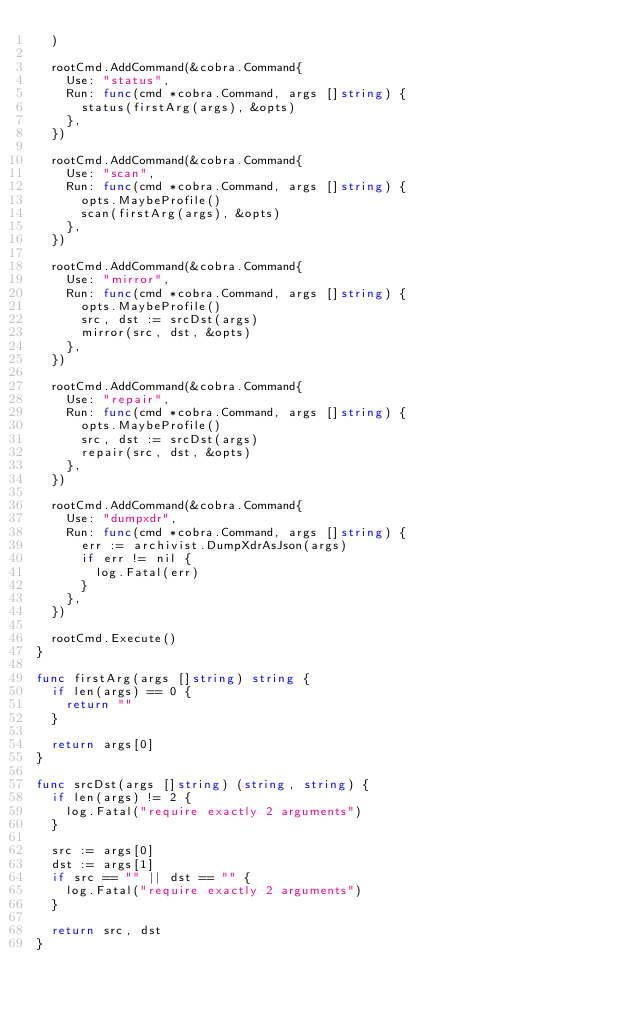<code> <loc_0><loc_0><loc_500><loc_500><_Go_>	)

	rootCmd.AddCommand(&cobra.Command{
		Use: "status",
		Run: func(cmd *cobra.Command, args []string) {
			status(firstArg(args), &opts)
		},
	})

	rootCmd.AddCommand(&cobra.Command{
		Use: "scan",
		Run: func(cmd *cobra.Command, args []string) {
			opts.MaybeProfile()
			scan(firstArg(args), &opts)
		},
	})

	rootCmd.AddCommand(&cobra.Command{
		Use: "mirror",
		Run: func(cmd *cobra.Command, args []string) {
			opts.MaybeProfile()
			src, dst := srcDst(args)
			mirror(src, dst, &opts)
		},
	})

	rootCmd.AddCommand(&cobra.Command{
		Use: "repair",
		Run: func(cmd *cobra.Command, args []string) {
			opts.MaybeProfile()
			src, dst := srcDst(args)
			repair(src, dst, &opts)
		},
	})

	rootCmd.AddCommand(&cobra.Command{
		Use: "dumpxdr",
		Run: func(cmd *cobra.Command, args []string) {
			err := archivist.DumpXdrAsJson(args)
			if err != nil {
				log.Fatal(err)
			}
		},
	})

	rootCmd.Execute()
}

func firstArg(args []string) string {
	if len(args) == 0 {
		return ""
	}

	return args[0]
}

func srcDst(args []string) (string, string) {
	if len(args) != 2 {
		log.Fatal("require exactly 2 arguments")
	}

	src := args[0]
	dst := args[1]
	if src == "" || dst == "" {
		log.Fatal("require exactly 2 arguments")
	}

	return src, dst
}
</code> 